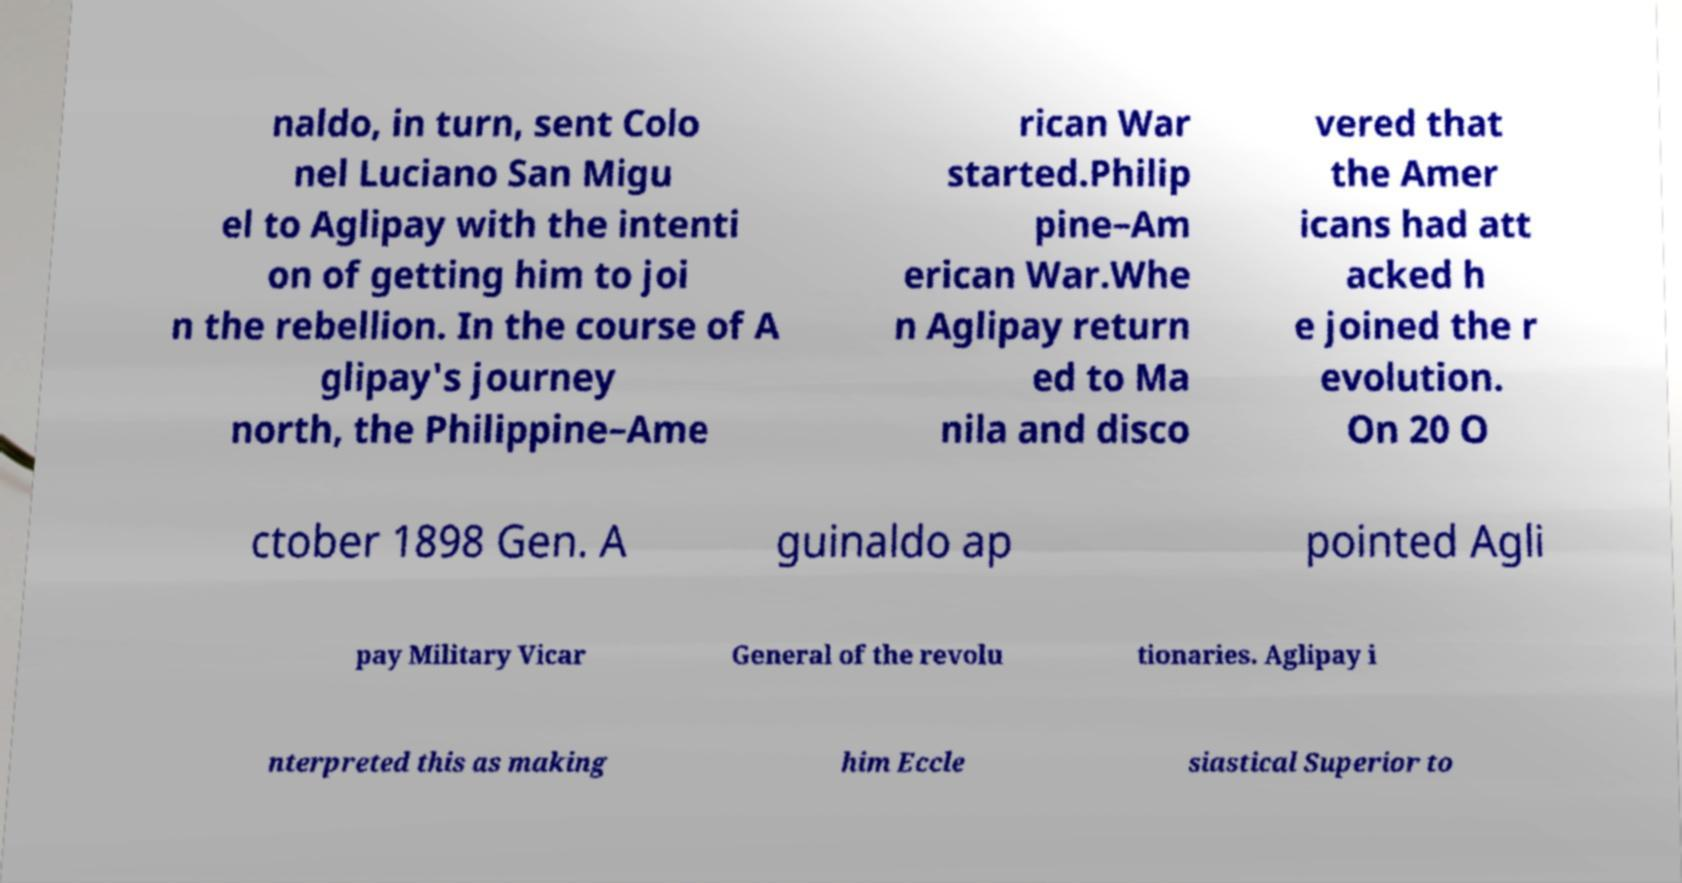What messages or text are displayed in this image? I need them in a readable, typed format. naldo, in turn, sent Colo nel Luciano San Migu el to Aglipay with the intenti on of getting him to joi n the rebellion. In the course of A glipay's journey north, the Philippine–Ame rican War started.Philip pine–Am erican War.Whe n Aglipay return ed to Ma nila and disco vered that the Amer icans had att acked h e joined the r evolution. On 20 O ctober 1898 Gen. A guinaldo ap pointed Agli pay Military Vicar General of the revolu tionaries. Aglipay i nterpreted this as making him Eccle siastical Superior to 